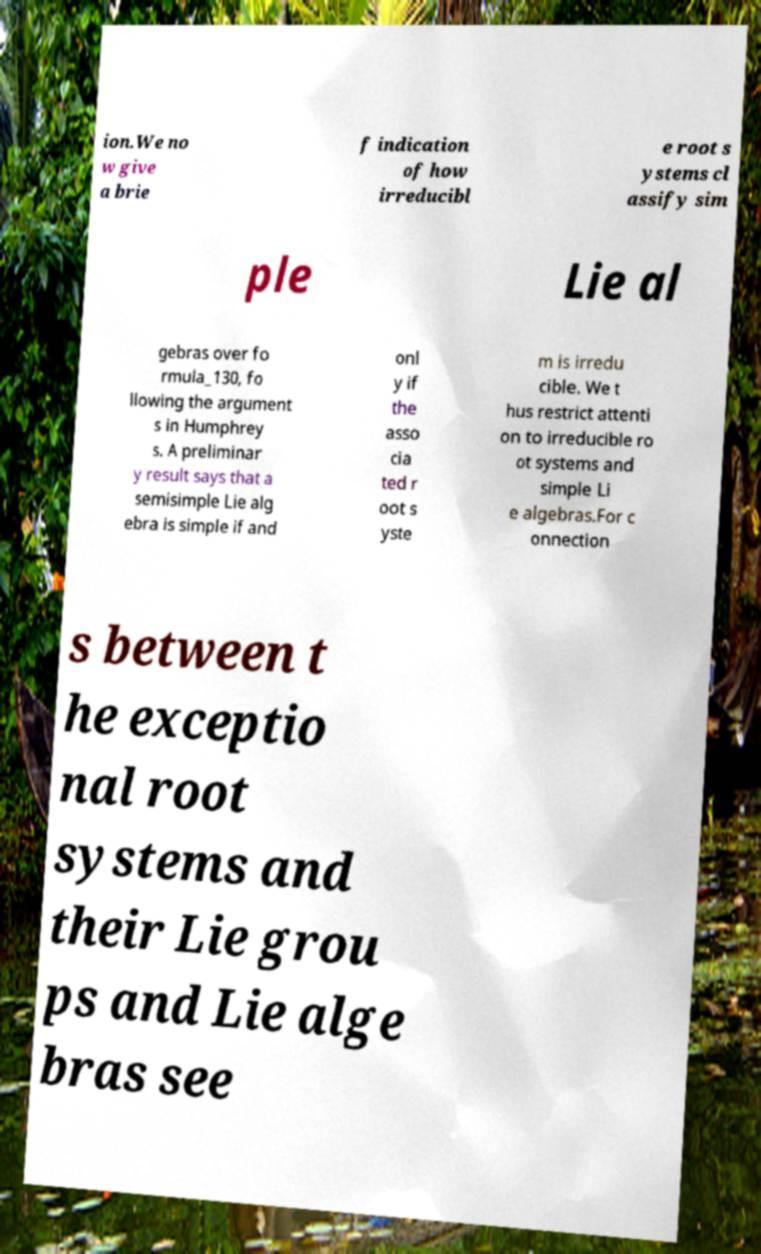I need the written content from this picture converted into text. Can you do that? ion.We no w give a brie f indication of how irreducibl e root s ystems cl assify sim ple Lie al gebras over fo rmula_130, fo llowing the argument s in Humphrey s. A preliminar y result says that a semisimple Lie alg ebra is simple if and onl y if the asso cia ted r oot s yste m is irredu cible. We t hus restrict attenti on to irreducible ro ot systems and simple Li e algebras.For c onnection s between t he exceptio nal root systems and their Lie grou ps and Lie alge bras see 